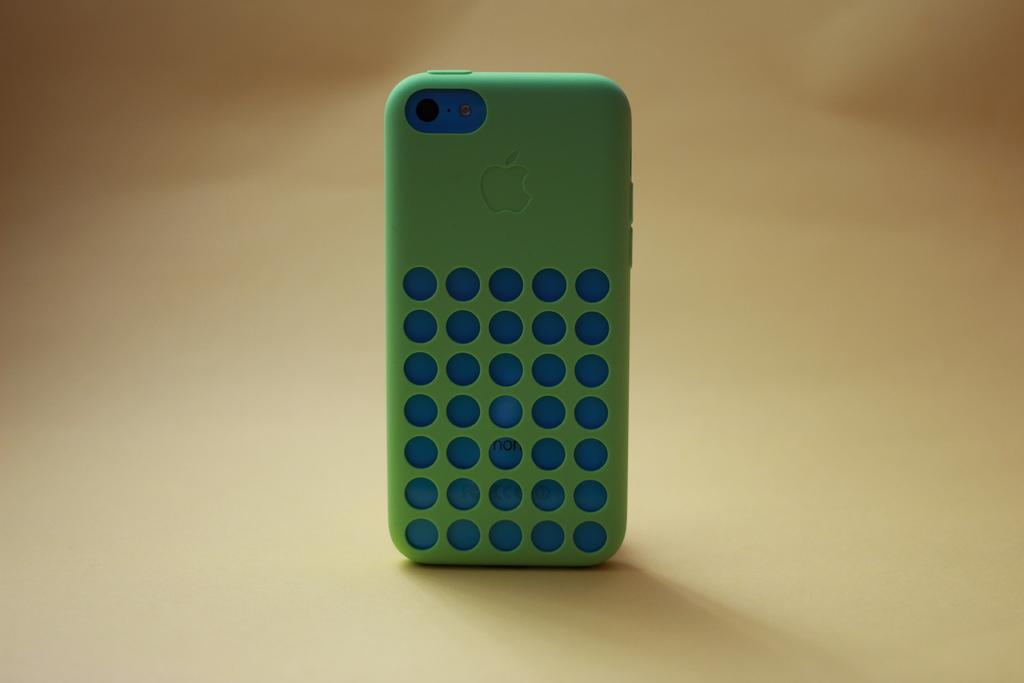What type of mobile is depicted in the image? There is an apple mobile in the image. What color is the back case of the mobile? The back case of the mobile is green in color. What is the plot of the story unfolding in the image? There is no story or plot depicted in the image, as it features an apple mobile with a green back case. 